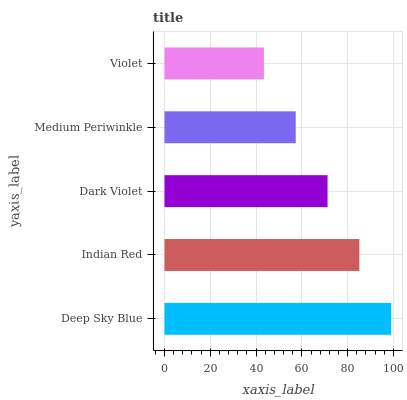Is Violet the minimum?
Answer yes or no. Yes. Is Deep Sky Blue the maximum?
Answer yes or no. Yes. Is Indian Red the minimum?
Answer yes or no. No. Is Indian Red the maximum?
Answer yes or no. No. Is Deep Sky Blue greater than Indian Red?
Answer yes or no. Yes. Is Indian Red less than Deep Sky Blue?
Answer yes or no. Yes. Is Indian Red greater than Deep Sky Blue?
Answer yes or no. No. Is Deep Sky Blue less than Indian Red?
Answer yes or no. No. Is Dark Violet the high median?
Answer yes or no. Yes. Is Dark Violet the low median?
Answer yes or no. Yes. Is Deep Sky Blue the high median?
Answer yes or no. No. Is Indian Red the low median?
Answer yes or no. No. 